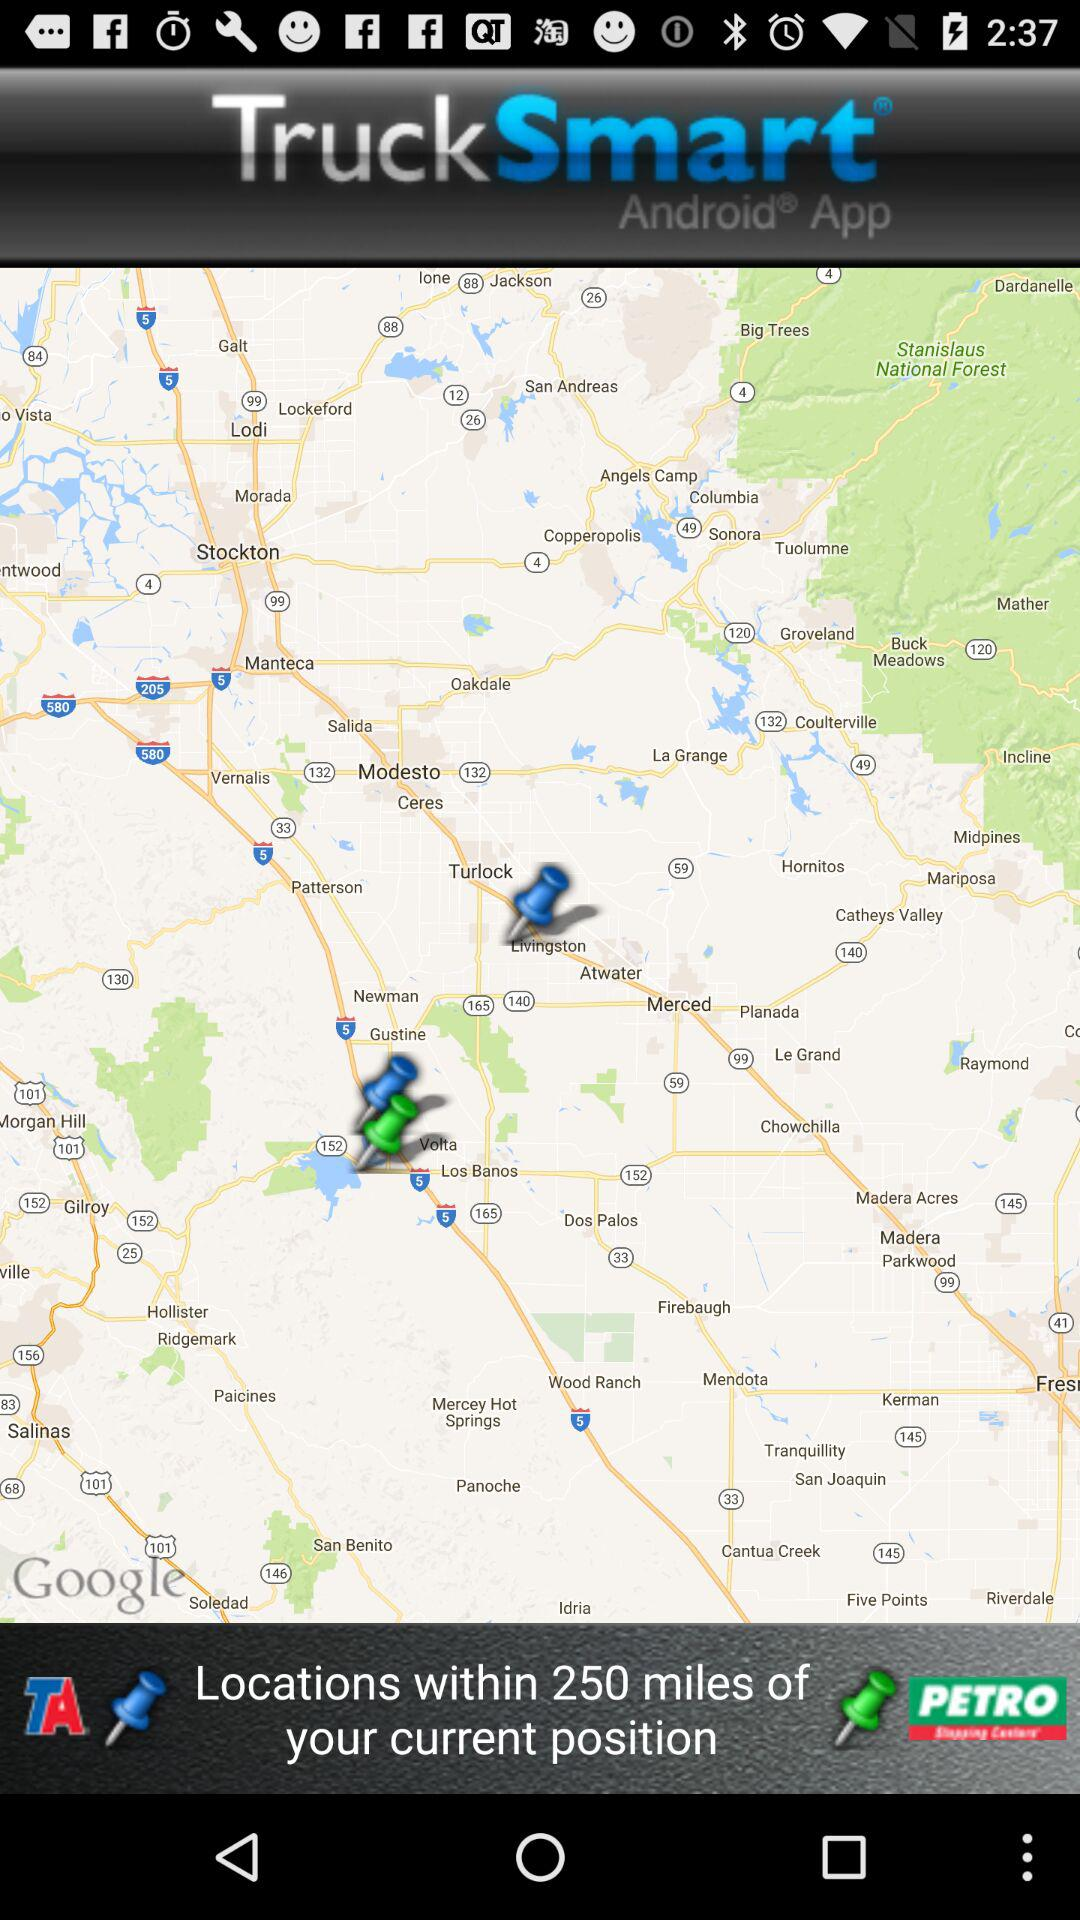How many different types of pins are on the map?
Answer the question using a single word or phrase. 2 